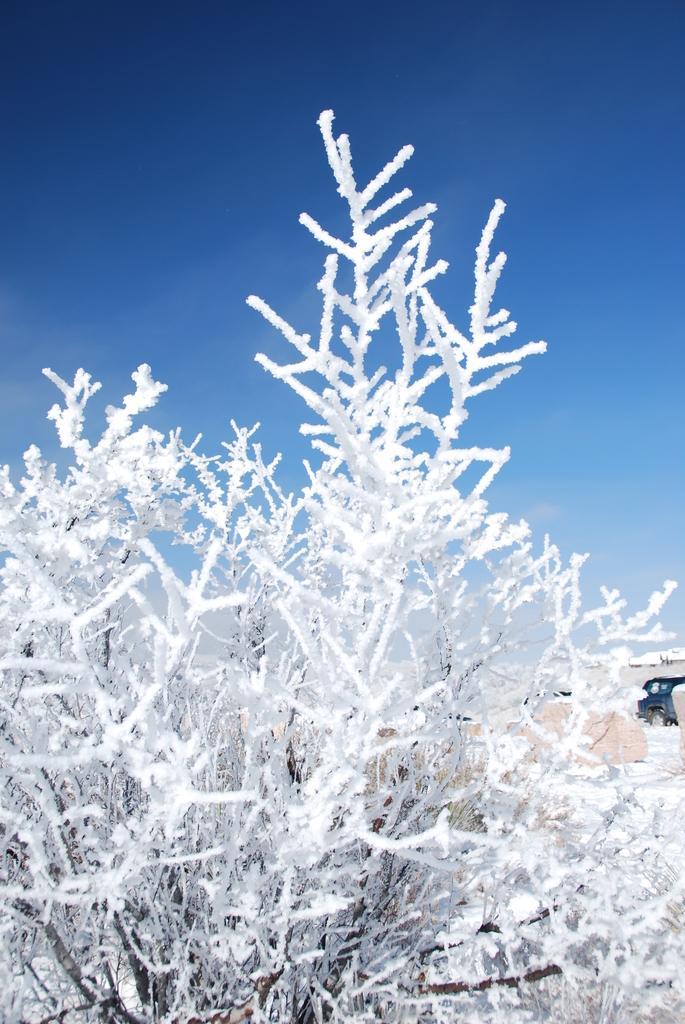In one or two sentences, can you explain what this image depicts? In this image I can see a plant which is filled with the snow. In the background there is a car. On the top of the image I can see the sky in blue color. 